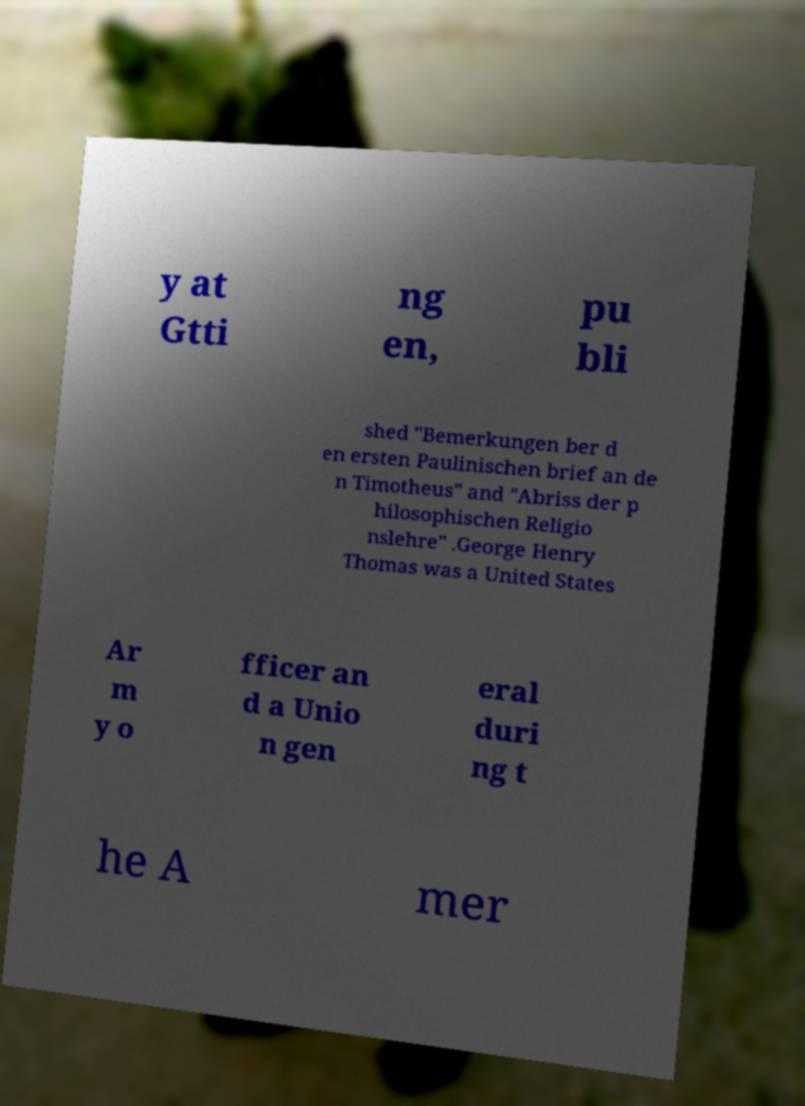I need the written content from this picture converted into text. Can you do that? y at Gtti ng en, pu bli shed "Bemerkungen ber d en ersten Paulinischen brief an de n Timotheus" and "Abriss der p hilosophischen Religio nslehre" .George Henry Thomas was a United States Ar m y o fficer an d a Unio n gen eral duri ng t he A mer 